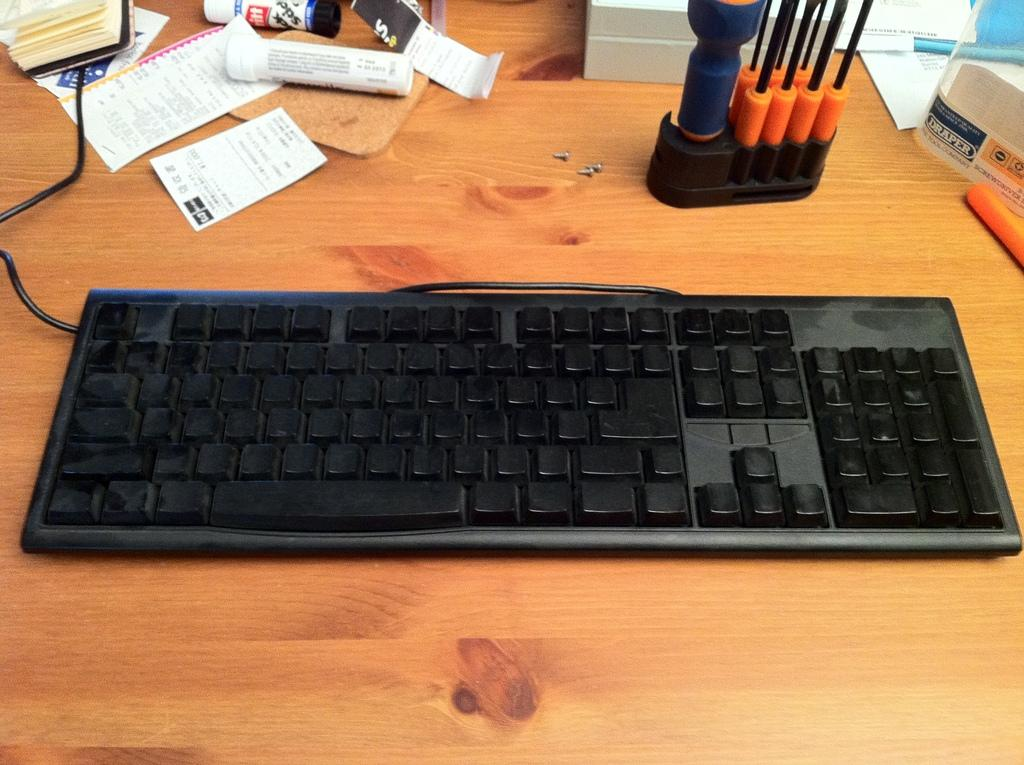<image>
Offer a succinct explanation of the picture presented. A black keyboard sits on a table with a sign for Draper and screwdrivers in the corner. 